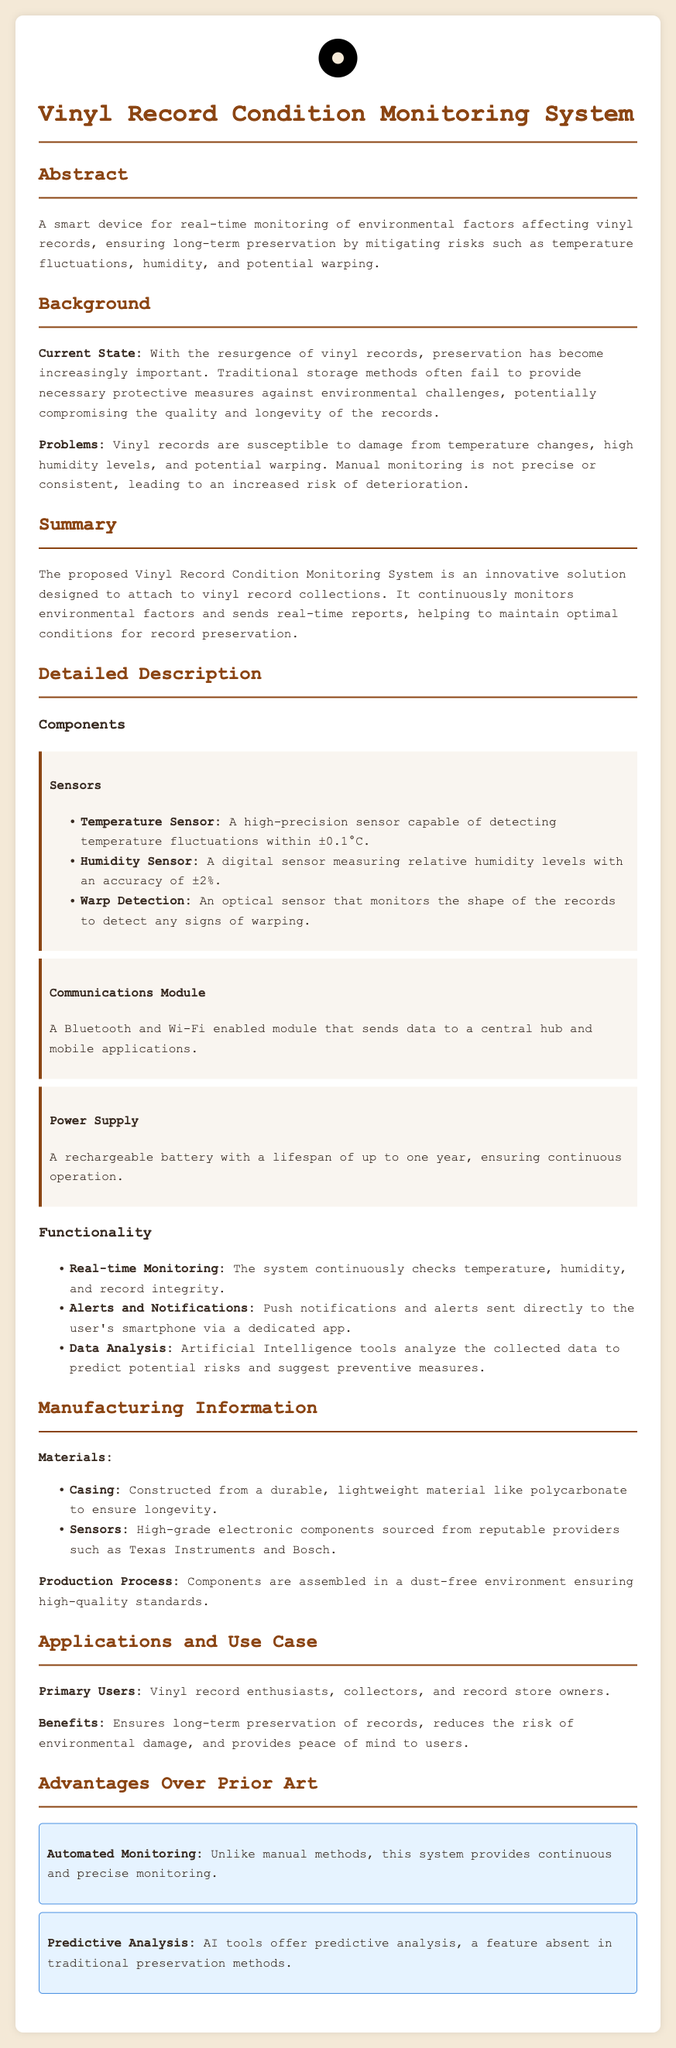what is the primary function of the Vinyl Record Condition Monitoring System? The primary function, as stated in the abstract, is to ensure long-term preservation by monitoring environmental factors.
Answer: monitoring environmental factors what type of sensors are included in the system? The detailed description mentions three types of sensors used in the system: temperature, humidity, and warp detection sensors.
Answer: temperature, humidity, warp detection how often does the system check the conditions? The functionality section states that the system continuously checks the conditions.
Answer: continuously what is the accuracy of the humidity sensor? The description of the humidity sensor specifies that it measures with an accuracy of ±2%.
Answer: ±2% who are the primary users of this system? The applications and use cases section outlines that the primary users are vinyl record enthusiasts, collectors, and record store owners.
Answer: vinyl record enthusiasts, collectors, and record store owners what major materials are used for the casing? The manufacturing information section tells us the casing is constructed from polycarbonate.
Answer: polycarbonate how does the system alert users? The functionality section mentions that alerts are sent directly to the user's smartphone via a dedicated app.
Answer: smartphone via a dedicated app what advantage does the system provide over manual monitoring? The advantages section states that the system provides automated and continuous monitoring, contrasting with manual methods.
Answer: automated monitoring how long does the rechargeable battery last? The detailed description indicates that the rechargeable battery has a lifespan of up to one year.
Answer: up to one year 